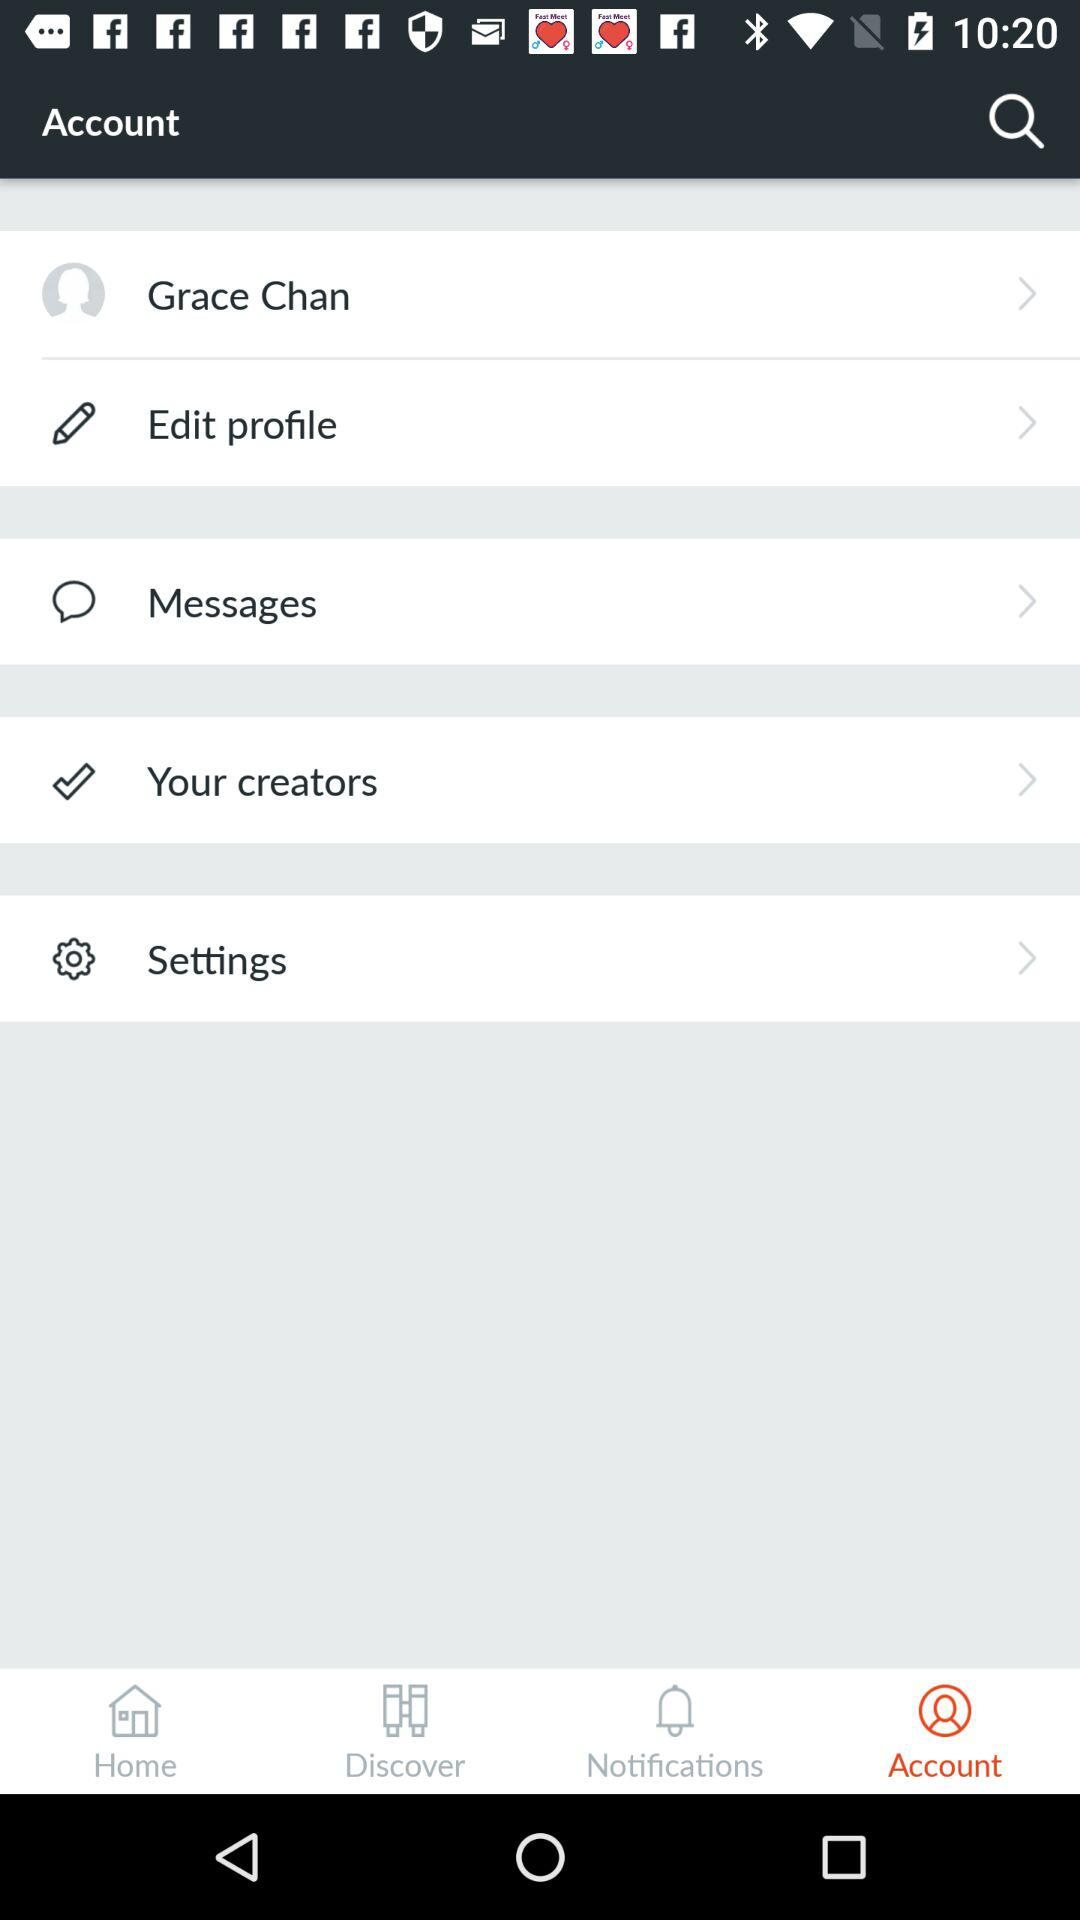What is the user name? The user name is Grace Chan. 